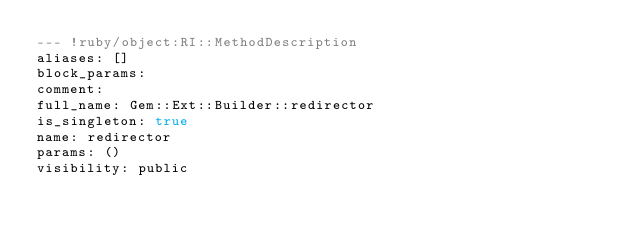Convert code to text. <code><loc_0><loc_0><loc_500><loc_500><_YAML_>--- !ruby/object:RI::MethodDescription 
aliases: []
block_params: 
comment: 
full_name: Gem::Ext::Builder::redirector
is_singleton: true
name: redirector
params: ()
visibility: public
</code> 